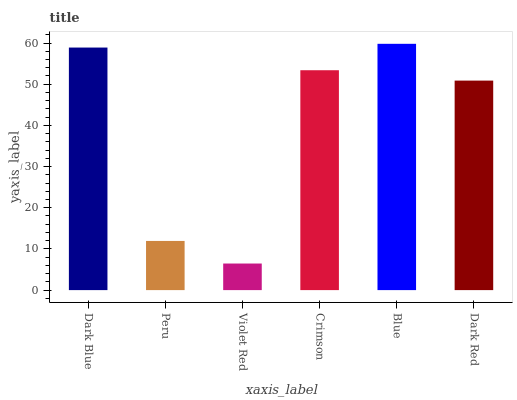Is Violet Red the minimum?
Answer yes or no. Yes. Is Blue the maximum?
Answer yes or no. Yes. Is Peru the minimum?
Answer yes or no. No. Is Peru the maximum?
Answer yes or no. No. Is Dark Blue greater than Peru?
Answer yes or no. Yes. Is Peru less than Dark Blue?
Answer yes or no. Yes. Is Peru greater than Dark Blue?
Answer yes or no. No. Is Dark Blue less than Peru?
Answer yes or no. No. Is Crimson the high median?
Answer yes or no. Yes. Is Dark Red the low median?
Answer yes or no. Yes. Is Violet Red the high median?
Answer yes or no. No. Is Crimson the low median?
Answer yes or no. No. 